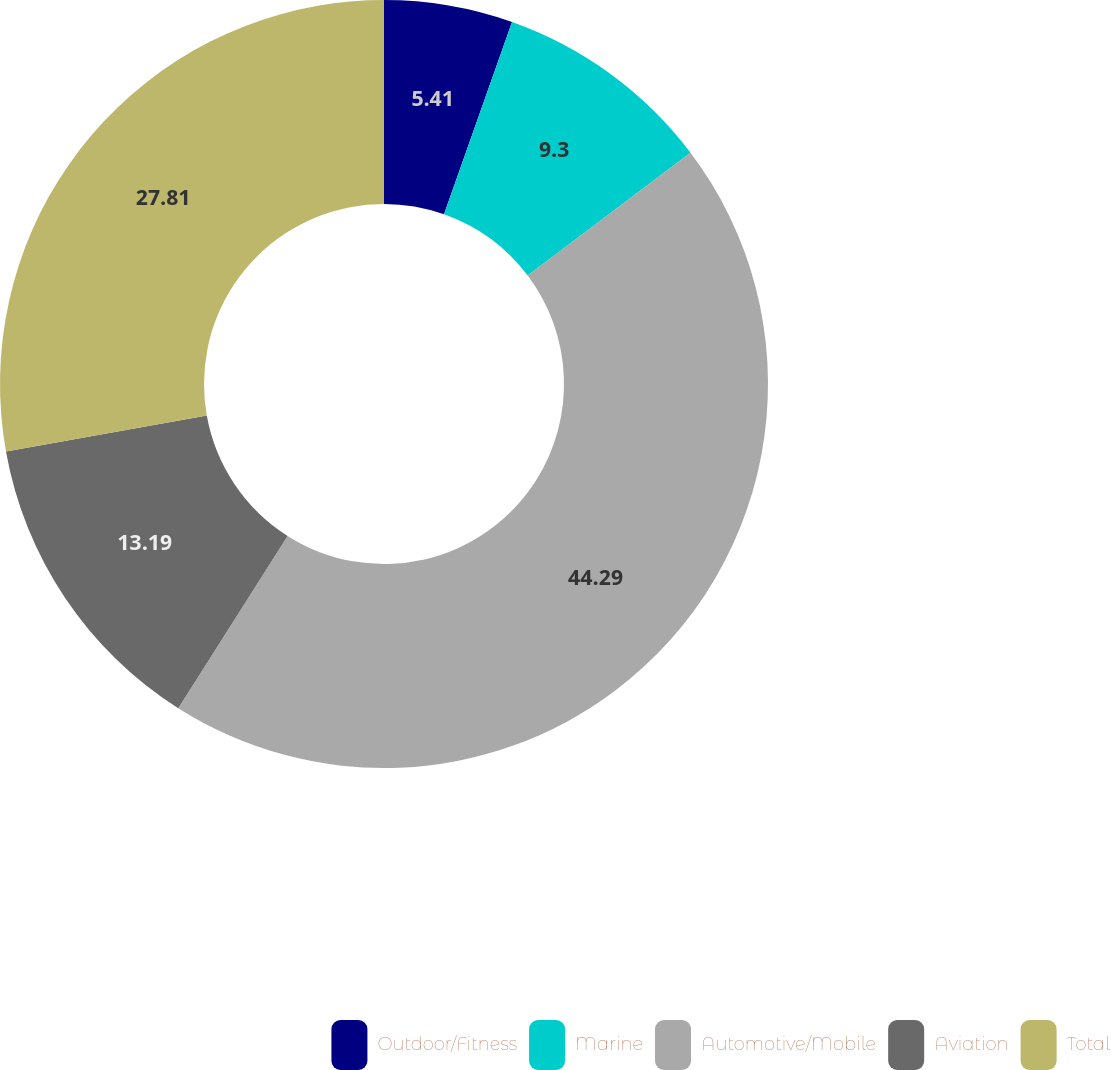Convert chart. <chart><loc_0><loc_0><loc_500><loc_500><pie_chart><fcel>Outdoor/Fitness<fcel>Marine<fcel>Automotive/Mobile<fcel>Aviation<fcel>Total<nl><fcel>5.41%<fcel>9.3%<fcel>44.29%<fcel>13.19%<fcel>27.81%<nl></chart> 